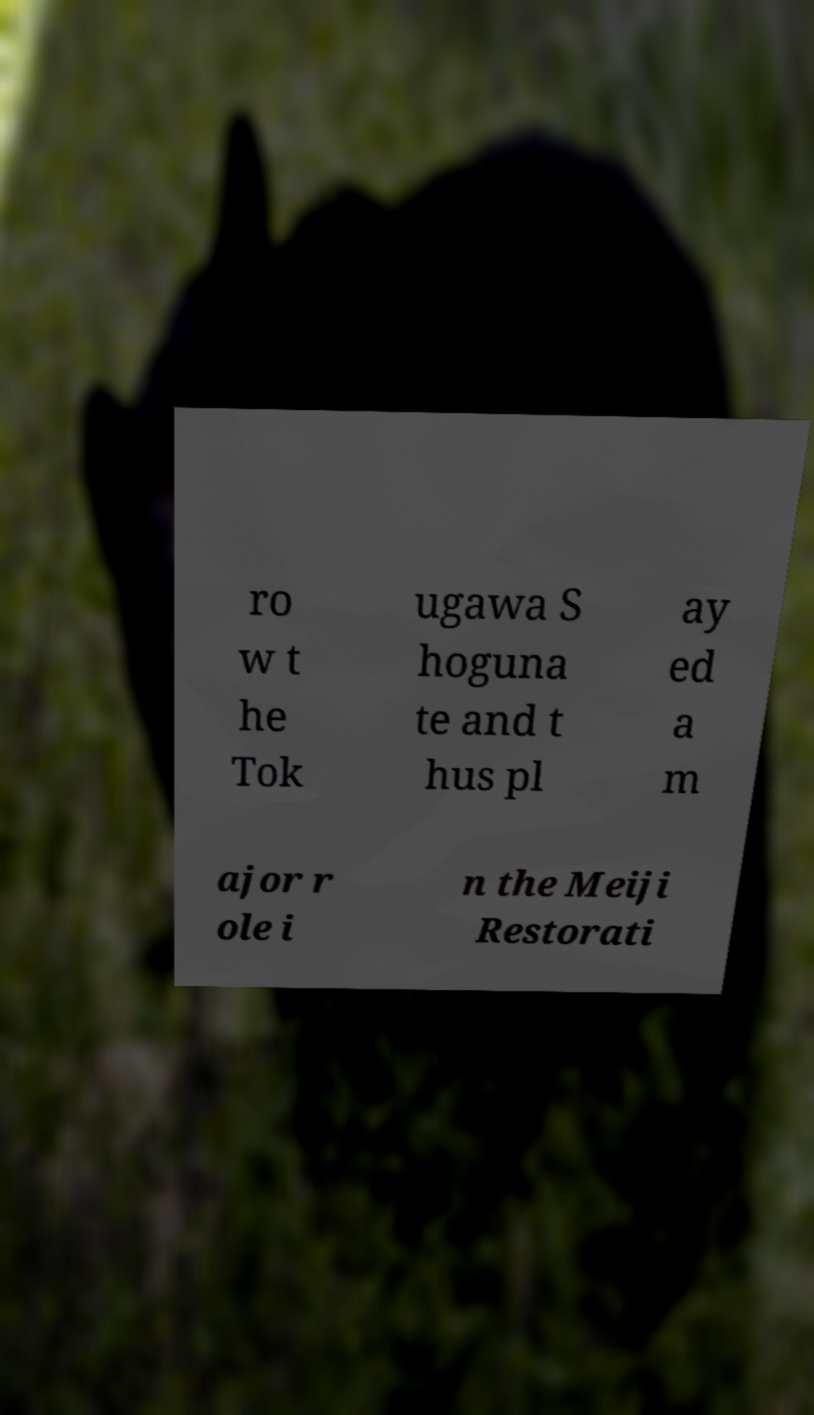Please read and relay the text visible in this image. What does it say? ro w t he Tok ugawa S hoguna te and t hus pl ay ed a m ajor r ole i n the Meiji Restorati 